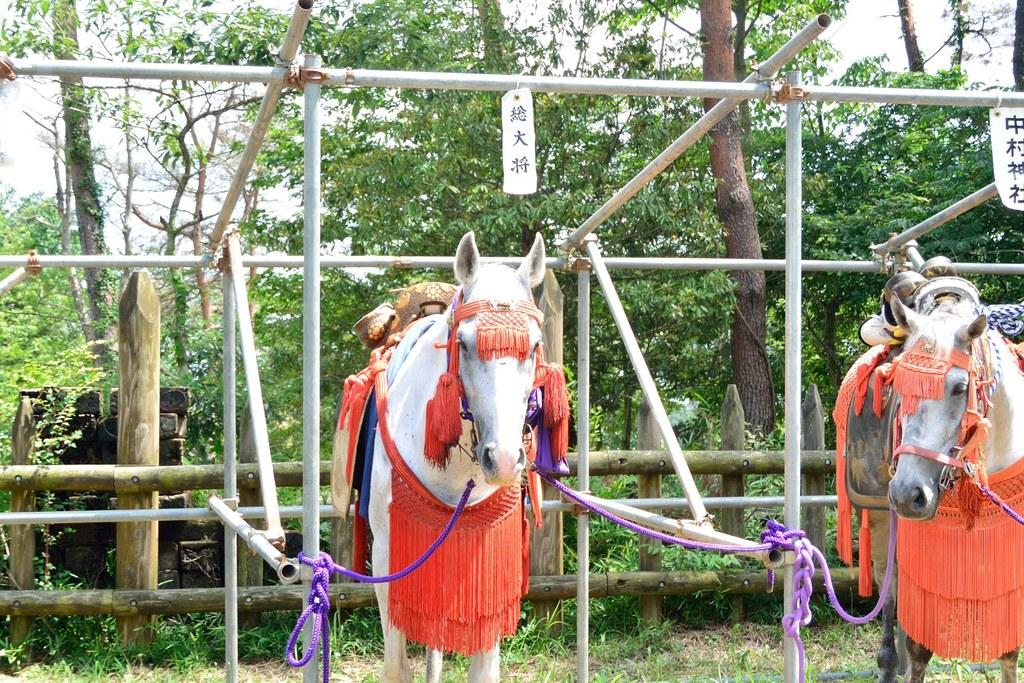How many horses are in the image? There are two horses in the image. What other objects can be seen in the image besides the horses? There are rods, ropes, wooden sticks, grass, trees, and some unspecified objects in the image. What type of vegetation is present in the image? There is grass and trees in the image. What is visible in the background of the image? The sky is visible in the background of the image. What type of cable can be seen connecting the two horses in the image? There is no cable connecting the two horses in the image; they are not physically connected. 